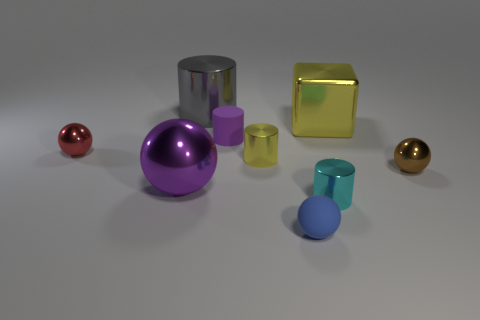What textures are visible on the objects in the image? The objects exhibit various textures: the red and gold spheres are shiny and reflective, the blue matte object and the purple cylinder have a dull, non-reflective finish, and the silver cylinder and gold cube appear somewhat glossy with light reflections. 